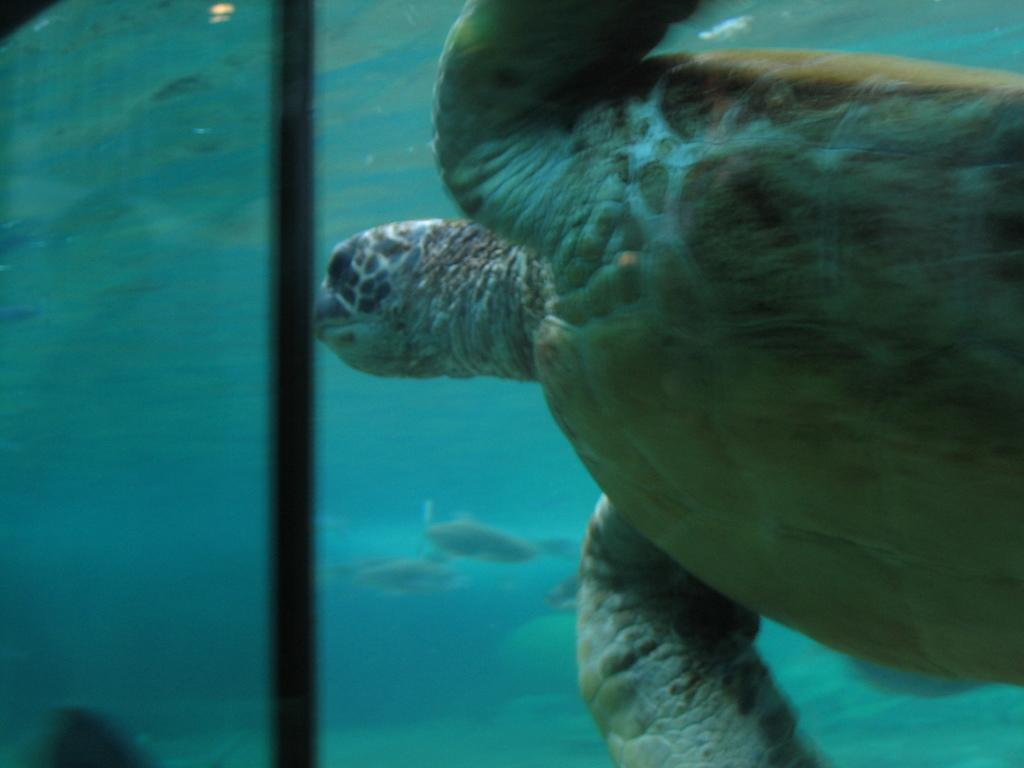What animal is present in the image? There is a turtle in the image. What is the turtle doing in the image? The turtle is swimming in the water. What can be seen in the background of the image? There are water bodies in the background of the image. What type of reward is the turtle receiving for swimming in the image? There is no indication in the image that the turtle is receiving a reward for swimming. 